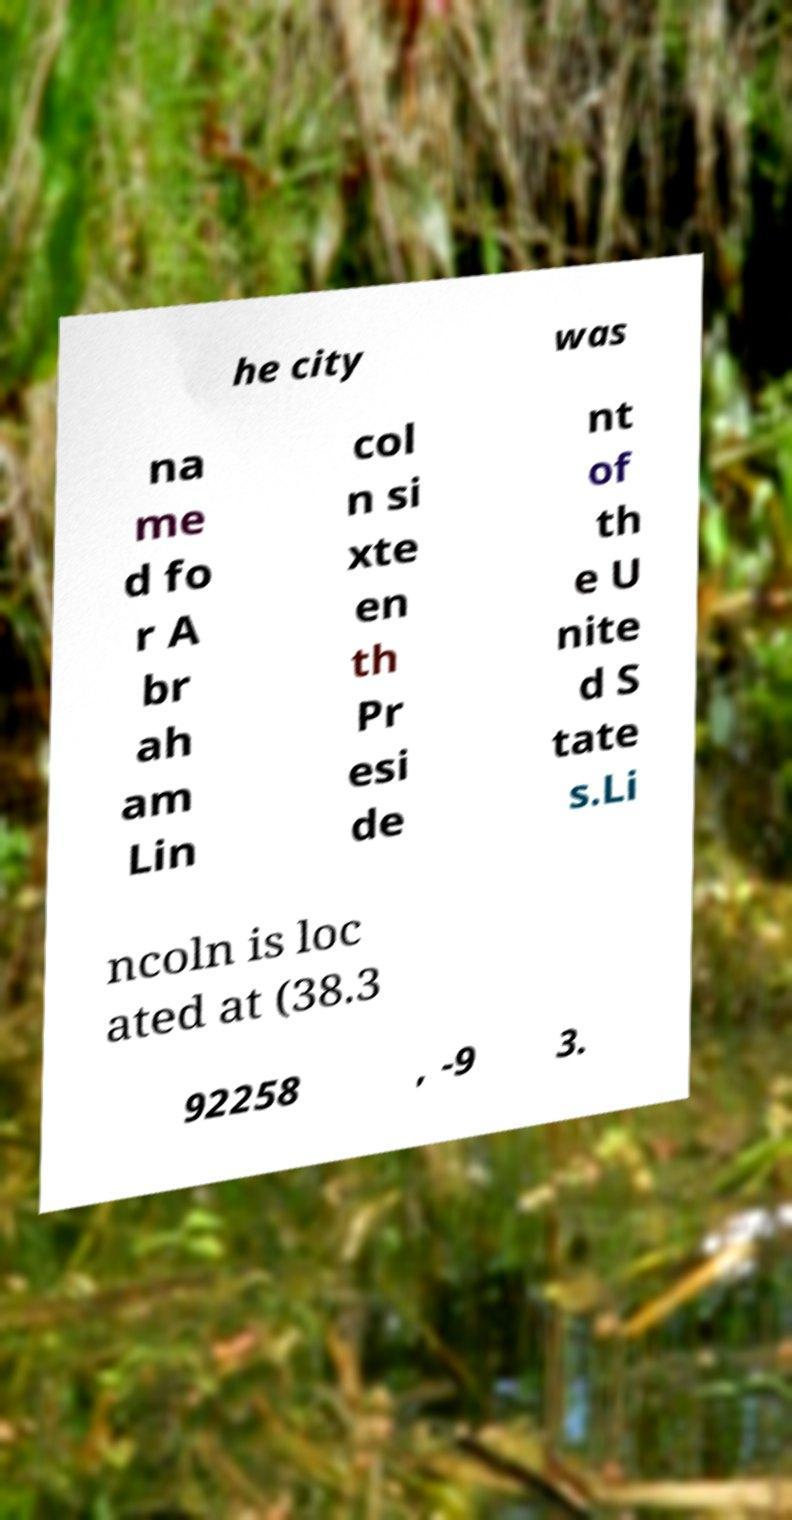Could you assist in decoding the text presented in this image and type it out clearly? he city was na me d fo r A br ah am Lin col n si xte en th Pr esi de nt of th e U nite d S tate s.Li ncoln is loc ated at (38.3 92258 , -9 3. 